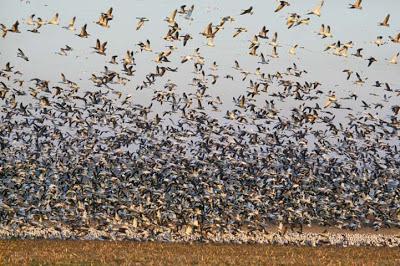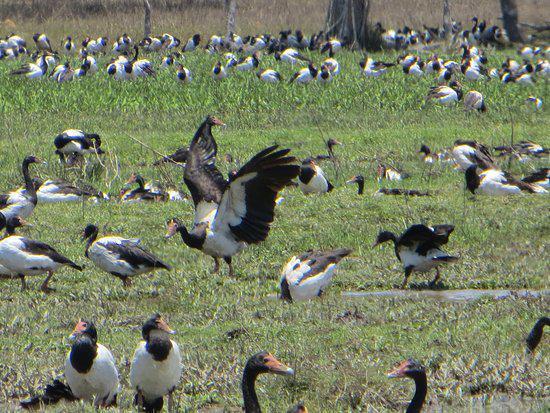The first image is the image on the left, the second image is the image on the right. Analyze the images presented: Is the assertion "In at least one image, there are multiple birds in flight" valid? Answer yes or no. Yes. The first image is the image on the left, the second image is the image on the right. Given the left and right images, does the statement "There is at least one person in one of the images." hold true? Answer yes or no. No. 